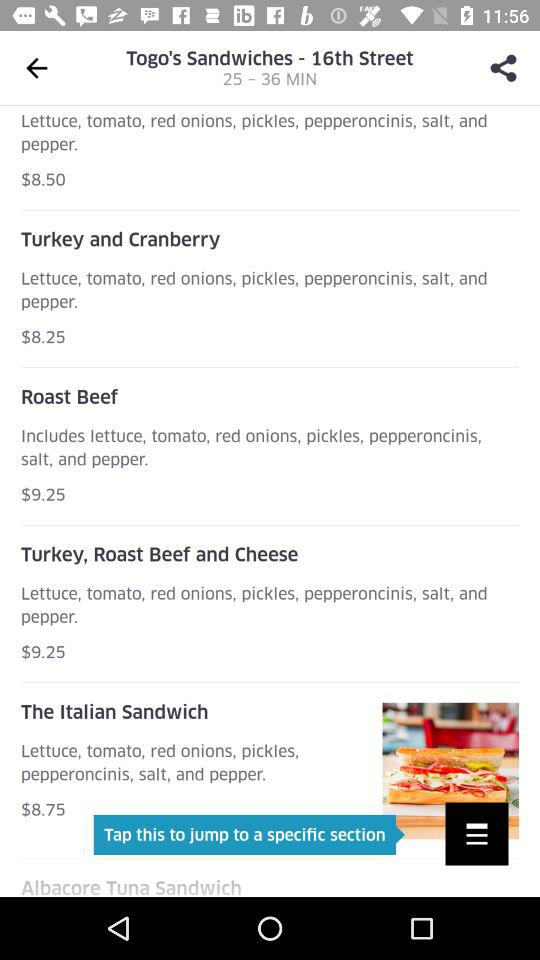What ingredients are used in "Turkey, Roast Beef and Cheese"? The ingredients used are "Lettuce, tomato, red onions, pickles, pepperoncinis, salt, and pepper". 